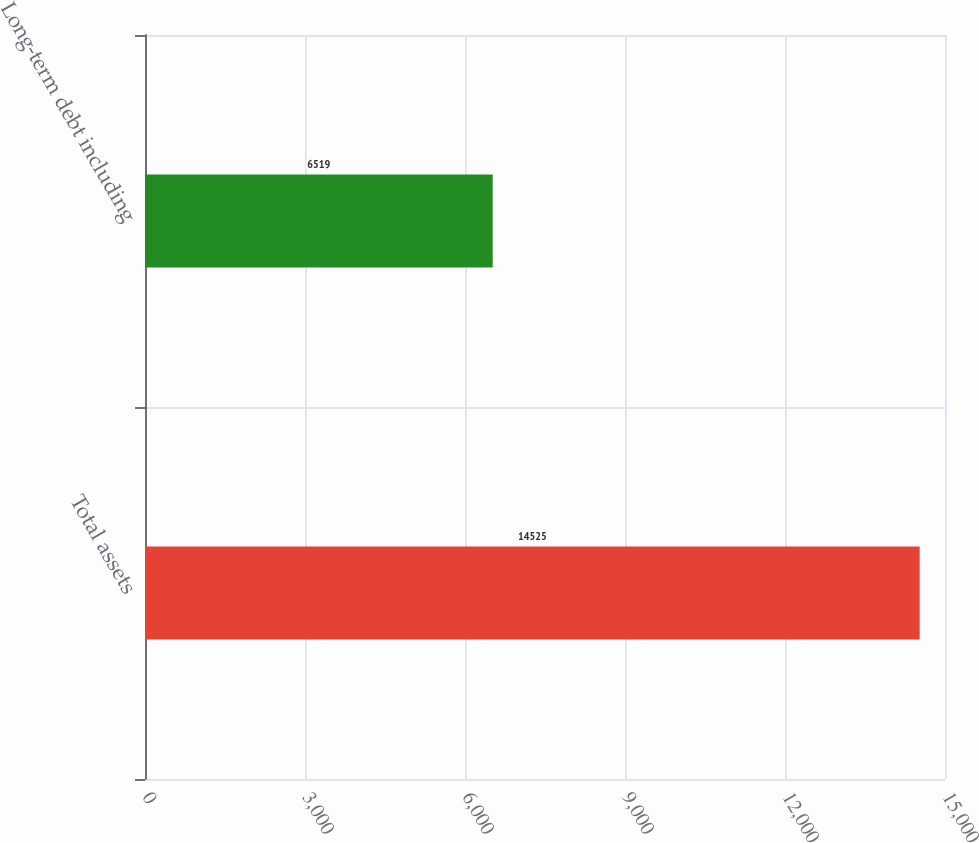Convert chart. <chart><loc_0><loc_0><loc_500><loc_500><bar_chart><fcel>Total assets<fcel>Long-term debt including<nl><fcel>14525<fcel>6519<nl></chart> 